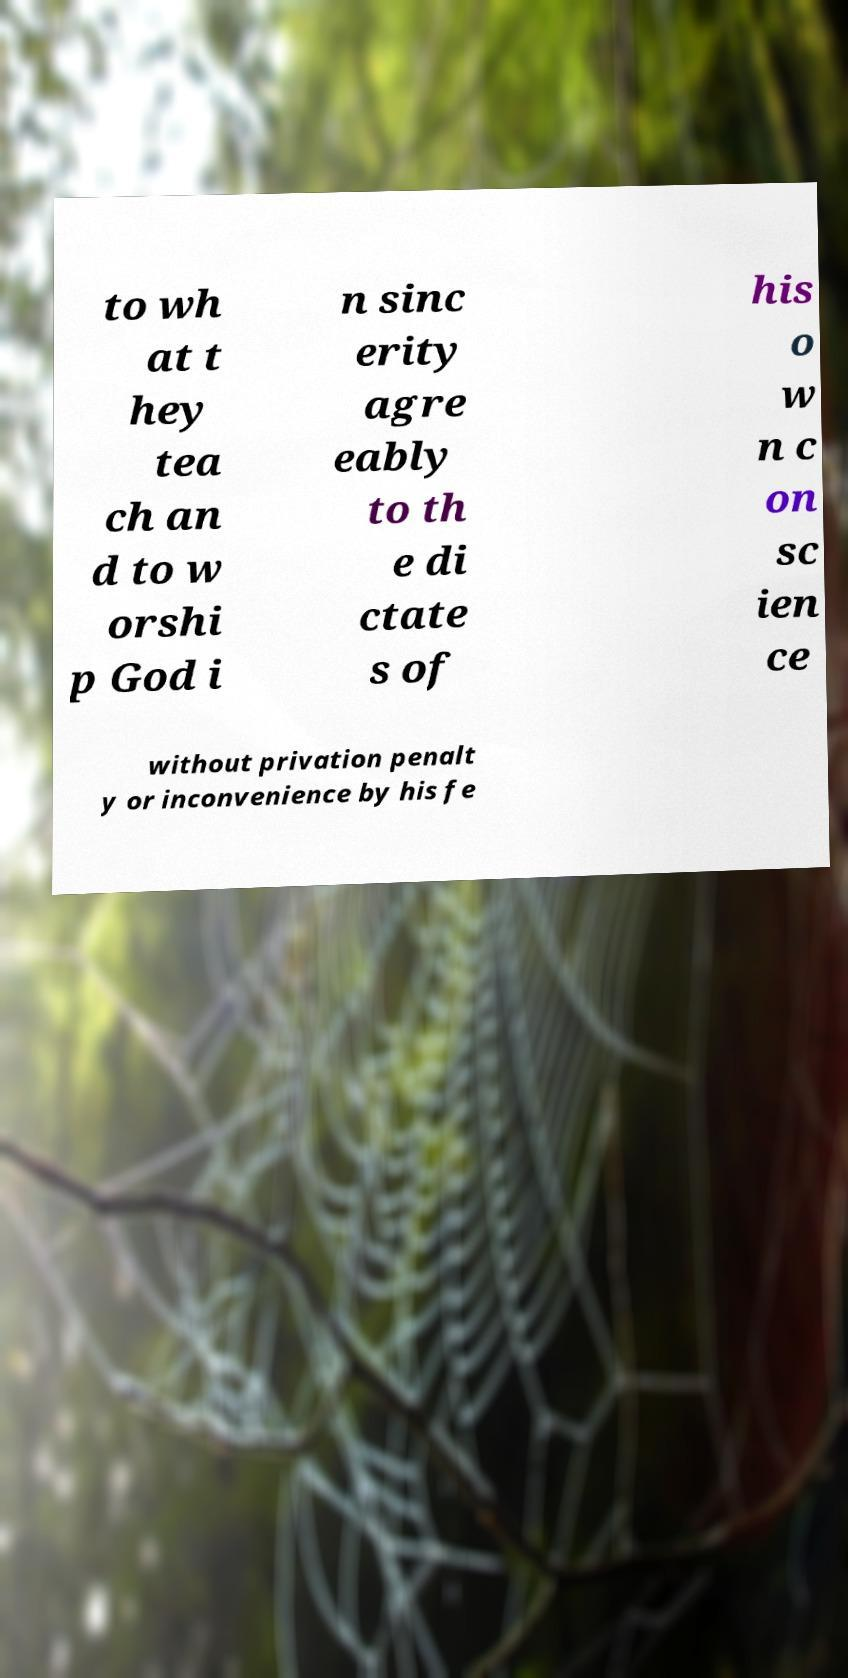Please read and relay the text visible in this image. What does it say? to wh at t hey tea ch an d to w orshi p God i n sinc erity agre eably to th e di ctate s of his o w n c on sc ien ce without privation penalt y or inconvenience by his fe 